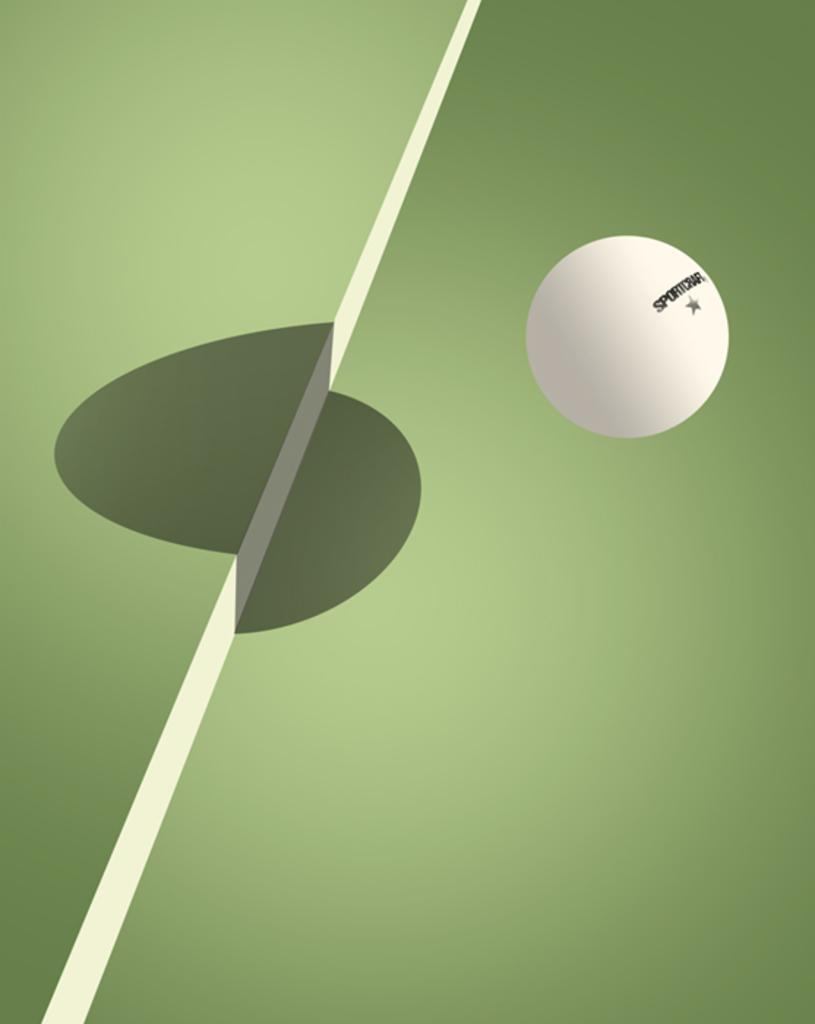What object is present in the image? There is a ball in the image. What is the color of the ball? The ball is white in color. Is there any text or image on the ball? Yes, something is written on the ball. What colors can be seen in the background of the image? The background of the image is white and green in color. How many strings are attached to the worm in the image? There is no worm or string present in the image. 